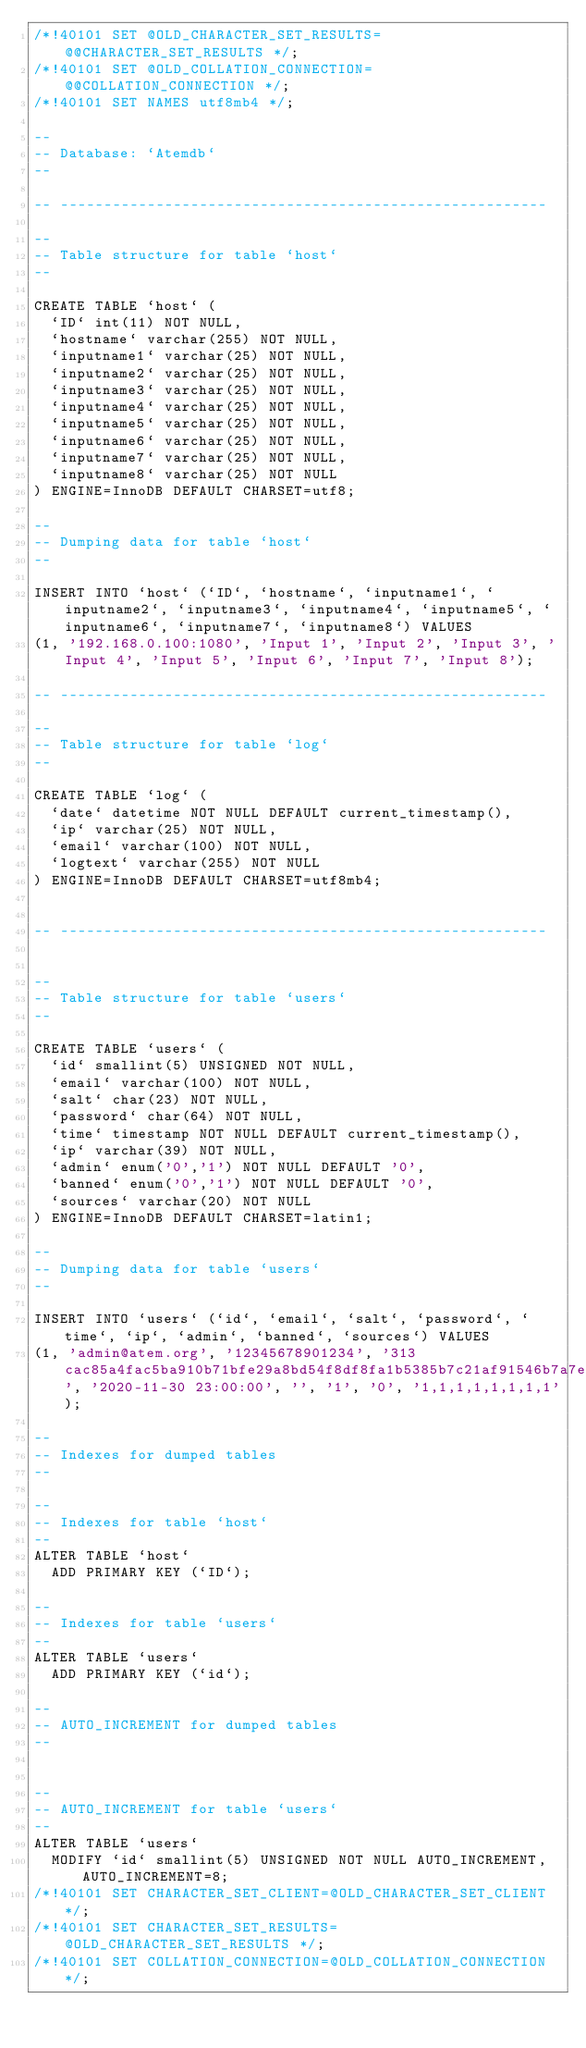Convert code to text. <code><loc_0><loc_0><loc_500><loc_500><_SQL_>/*!40101 SET @OLD_CHARACTER_SET_RESULTS=@@CHARACTER_SET_RESULTS */;
/*!40101 SET @OLD_COLLATION_CONNECTION=@@COLLATION_CONNECTION */;
/*!40101 SET NAMES utf8mb4 */;

--
-- Database: `Atemdb`
--

-- --------------------------------------------------------

--
-- Table structure for table `host`
--

CREATE TABLE `host` (
  `ID` int(11) NOT NULL,
  `hostname` varchar(255) NOT NULL,
  `inputname1` varchar(25) NOT NULL,
  `inputname2` varchar(25) NOT NULL,
  `inputname3` varchar(25) NOT NULL,
  `inputname4` varchar(25) NOT NULL,
  `inputname5` varchar(25) NOT NULL,
  `inputname6` varchar(25) NOT NULL,
  `inputname7` varchar(25) NOT NULL,
  `inputname8` varchar(25) NOT NULL
) ENGINE=InnoDB DEFAULT CHARSET=utf8;

--
-- Dumping data for table `host`
--

INSERT INTO `host` (`ID`, `hostname`, `inputname1`, `inputname2`, `inputname3`, `inputname4`, `inputname5`, `inputname6`, `inputname7`, `inputname8`) VALUES
(1, '192.168.0.100:1080', 'Input 1', 'Input 2', 'Input 3', 'Input 4', 'Input 5', 'Input 6', 'Input 7', 'Input 8');

-- --------------------------------------------------------

--
-- Table structure for table `log`
--

CREATE TABLE `log` (
  `date` datetime NOT NULL DEFAULT current_timestamp(),
  `ip` varchar(25) NOT NULL,
  `email` varchar(100) NOT NULL,
  `logtext` varchar(255) NOT NULL
) ENGINE=InnoDB DEFAULT CHARSET=utf8mb4;


-- --------------------------------------------------------


--
-- Table structure for table `users`
--

CREATE TABLE `users` (
  `id` smallint(5) UNSIGNED NOT NULL,
  `email` varchar(100) NOT NULL,
  `salt` char(23) NOT NULL,
  `password` char(64) NOT NULL,
  `time` timestamp NOT NULL DEFAULT current_timestamp(),
  `ip` varchar(39) NOT NULL,
  `admin` enum('0','1') NOT NULL DEFAULT '0',
  `banned` enum('0','1') NOT NULL DEFAULT '0',
  `sources` varchar(20) NOT NULL
) ENGINE=InnoDB DEFAULT CHARSET=latin1;

--
-- Dumping data for table `users`
--

INSERT INTO `users` (`id`, `email`, `salt`, `password`, `time`, `ip`, `admin`, `banned`, `sources`) VALUES
(1, 'admin@atem.org', '12345678901234', '313cac85a4fac5ba910b71bfe29a8bd54f8df8fa1b5385b7c21af91546b7a7ef', '2020-11-30 23:00:00', '', '1', '0', '1,1,1,1,1,1,1,1');

--
-- Indexes for dumped tables
--

--
-- Indexes for table `host`
--
ALTER TABLE `host`
  ADD PRIMARY KEY (`ID`);

--
-- Indexes for table `users`
--
ALTER TABLE `users`
  ADD PRIMARY KEY (`id`);

--
-- AUTO_INCREMENT for dumped tables
--


--
-- AUTO_INCREMENT for table `users`
--
ALTER TABLE `users`
  MODIFY `id` smallint(5) UNSIGNED NOT NULL AUTO_INCREMENT, AUTO_INCREMENT=8;
/*!40101 SET CHARACTER_SET_CLIENT=@OLD_CHARACTER_SET_CLIENT */;
/*!40101 SET CHARACTER_SET_RESULTS=@OLD_CHARACTER_SET_RESULTS */;
/*!40101 SET COLLATION_CONNECTION=@OLD_COLLATION_CONNECTION */;
</code> 